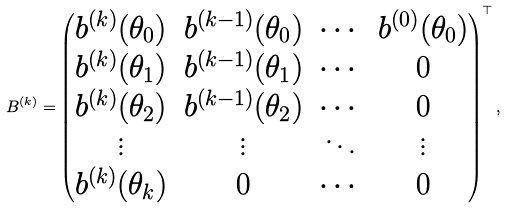Convert formula to latex. <formula><loc_0><loc_0><loc_500><loc_500>B ^ { ( k ) } = \begin{pmatrix} b ^ { ( k ) } ( \theta _ { 0 } ) & b ^ { ( k - 1 ) } ( \theta _ { 0 } ) & \cdots & b ^ { ( 0 ) } ( \theta _ { 0 } ) \\ b ^ { ( k ) } ( \theta _ { 1 } ) & b ^ { ( k - 1 ) } ( \theta _ { 1 } ) & \cdots & 0 \\ b ^ { ( k ) } ( \theta _ { 2 } ) & b ^ { ( k - 1 ) } ( \theta _ { 2 } ) & \cdots & 0 \\ \vdots & \vdots & \ddots & \vdots \\ b ^ { ( k ) } ( \theta _ { k } ) & 0 & \cdots & 0 \end{pmatrix} ^ { \top } ,</formula> 